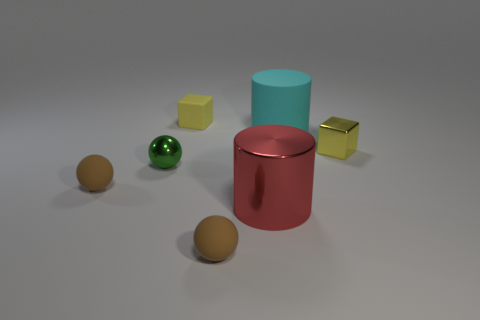How many brown balls must be subtracted to get 1 brown balls? 1 Subtract all green balls. How many balls are left? 2 Subtract all spheres. How many objects are left? 4 Subtract 1 cylinders. How many cylinders are left? 1 Subtract all gray balls. Subtract all green cylinders. How many balls are left? 3 Subtract all blue spheres. How many gray cylinders are left? 0 Subtract all green metallic objects. Subtract all large red cylinders. How many objects are left? 5 Add 1 green shiny balls. How many green shiny balls are left? 2 Add 1 small yellow shiny objects. How many small yellow shiny objects exist? 2 Add 3 tiny green metal things. How many objects exist? 10 